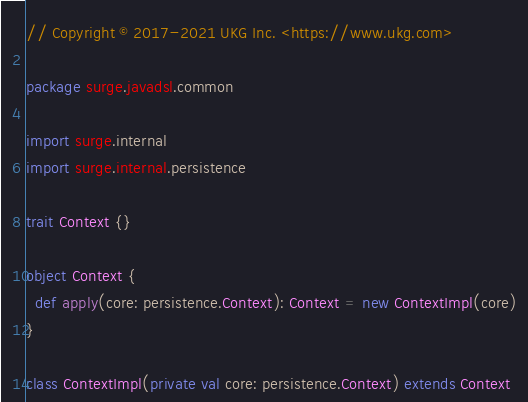<code> <loc_0><loc_0><loc_500><loc_500><_Scala_>// Copyright © 2017-2021 UKG Inc. <https://www.ukg.com>

package surge.javadsl.common

import surge.internal
import surge.internal.persistence

trait Context {}

object Context {
  def apply(core: persistence.Context): Context = new ContextImpl(core)
}

class ContextImpl(private val core: persistence.Context) extends Context
</code> 